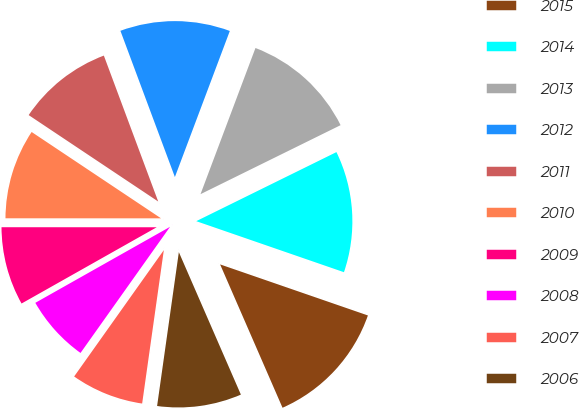Convert chart. <chart><loc_0><loc_0><loc_500><loc_500><pie_chart><fcel>2015<fcel>2014<fcel>2013<fcel>2012<fcel>2011<fcel>2010<fcel>2009<fcel>2008<fcel>2007<fcel>2006<nl><fcel>13.17%<fcel>12.58%<fcel>11.99%<fcel>11.4%<fcel>9.96%<fcel>9.36%<fcel>8.18%<fcel>7.0%<fcel>7.59%<fcel>8.77%<nl></chart> 